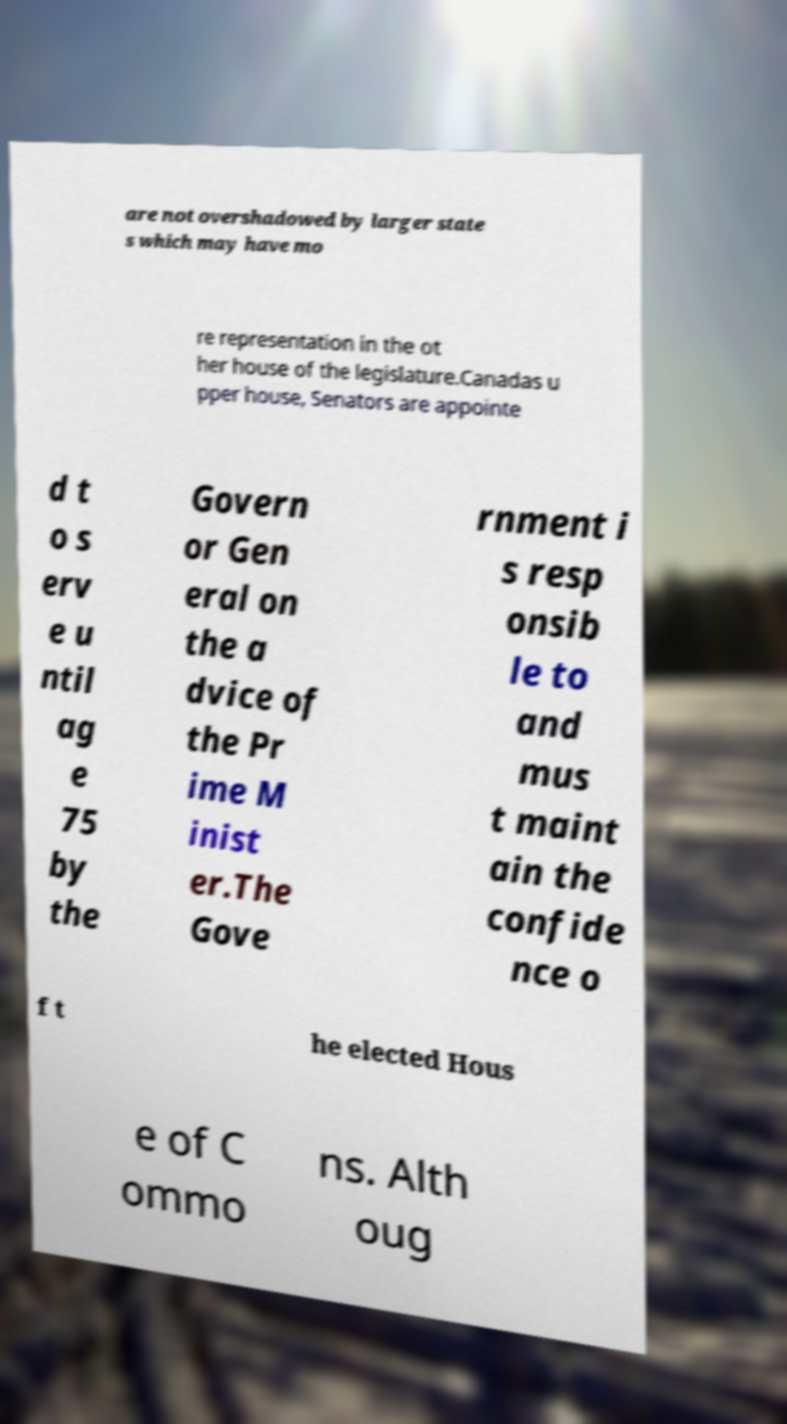Please read and relay the text visible in this image. What does it say? are not overshadowed by larger state s which may have mo re representation in the ot her house of the legislature.Canadas u pper house, Senators are appointe d t o s erv e u ntil ag e 75 by the Govern or Gen eral on the a dvice of the Pr ime M inist er.The Gove rnment i s resp onsib le to and mus t maint ain the confide nce o f t he elected Hous e of C ommo ns. Alth oug 